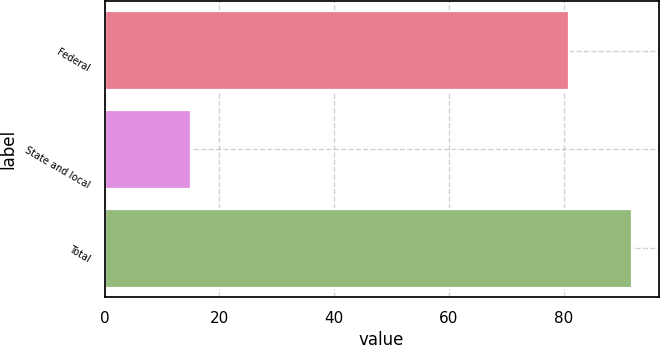Convert chart to OTSL. <chart><loc_0><loc_0><loc_500><loc_500><bar_chart><fcel>Federal<fcel>State and local<fcel>Total<nl><fcel>81<fcel>15<fcel>92<nl></chart> 